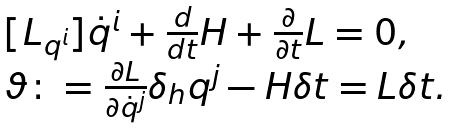<formula> <loc_0><loc_0><loc_500><loc_500>\begin{array} { l } [ { L } _ { q ^ { i } } ] \dot { q } ^ { i } + \frac { d } { d t } { H } + \frac { \partial } { \partial t } { L } = 0 , \\ \vartheta \colon = \frac { \partial { L } } { \partial \dot { q } ^ { j } } \delta _ { h } q ^ { j } - { H } \delta t = { L } \delta t . \end{array}</formula> 